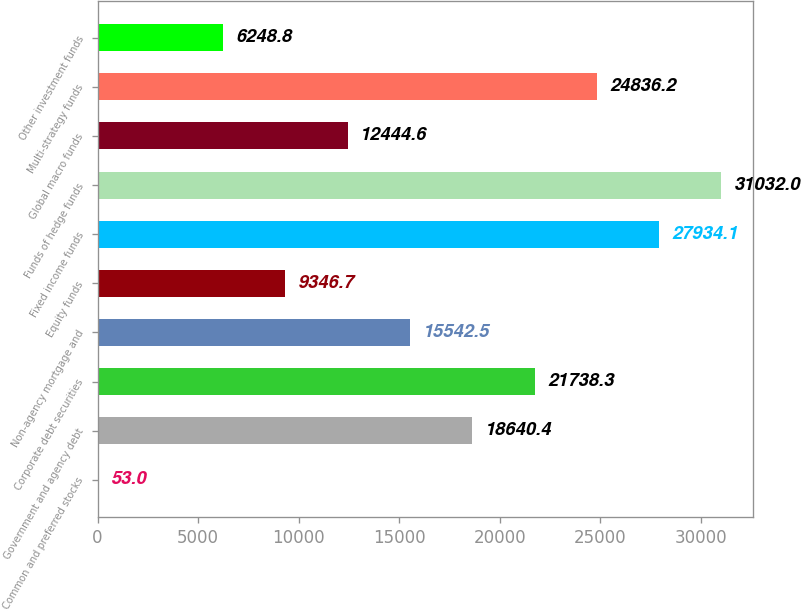<chart> <loc_0><loc_0><loc_500><loc_500><bar_chart><fcel>Common and preferred stocks<fcel>Government and agency debt<fcel>Corporate debt securities<fcel>Non-agency mortgage and<fcel>Equity funds<fcel>Fixed income funds<fcel>Funds of hedge funds<fcel>Global macro funds<fcel>Multi-strategy funds<fcel>Other investment funds<nl><fcel>53<fcel>18640.4<fcel>21738.3<fcel>15542.5<fcel>9346.7<fcel>27934.1<fcel>31032<fcel>12444.6<fcel>24836.2<fcel>6248.8<nl></chart> 